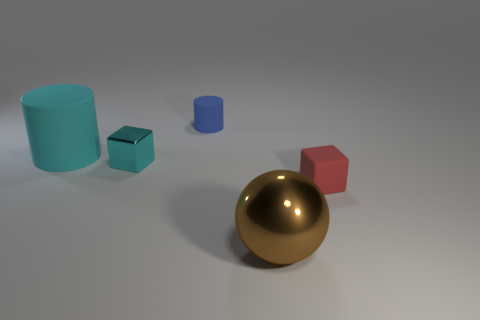What size is the shiny cube that is the same color as the large matte cylinder?
Your response must be concise. Small. What number of shiny objects have the same shape as the small red matte object?
Provide a short and direct response. 1. Does the cyan object to the right of the big rubber object have the same material as the tiny cylinder?
Provide a short and direct response. No. What number of cylinders are big yellow shiny things or tiny cyan metallic things?
Ensure brevity in your answer.  0. The small matte object that is behind the small object that is on the left side of the matte thing that is behind the big cyan object is what shape?
Your answer should be compact. Cylinder. There is a tiny metallic object that is the same color as the big matte cylinder; what is its shape?
Your response must be concise. Cube. How many cyan cubes have the same size as the red thing?
Offer a terse response. 1. There is a small block right of the large brown thing; are there any balls behind it?
Offer a very short reply. No. How many things are large matte cylinders or big red metal balls?
Give a very brief answer. 1. There is a small thing behind the cyan object to the left of the shiny object that is behind the brown metal ball; what is its color?
Ensure brevity in your answer.  Blue. 